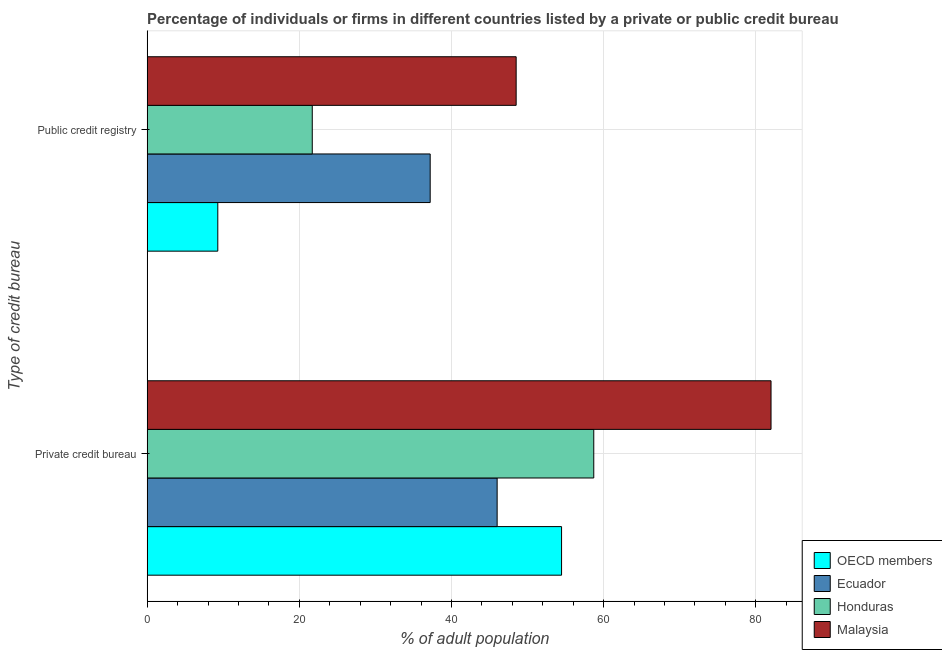How many different coloured bars are there?
Your answer should be compact. 4. Are the number of bars per tick equal to the number of legend labels?
Offer a terse response. Yes. Are the number of bars on each tick of the Y-axis equal?
Provide a succinct answer. Yes. How many bars are there on the 2nd tick from the top?
Make the answer very short. 4. How many bars are there on the 2nd tick from the bottom?
Offer a very short reply. 4. What is the label of the 1st group of bars from the top?
Your response must be concise. Public credit registry. What is the percentage of firms listed by private credit bureau in Malaysia?
Your answer should be compact. 82. Across all countries, what is the maximum percentage of firms listed by public credit bureau?
Give a very brief answer. 48.5. In which country was the percentage of firms listed by private credit bureau maximum?
Give a very brief answer. Malaysia. What is the total percentage of firms listed by public credit bureau in the graph?
Make the answer very short. 116.68. What is the difference between the percentage of firms listed by private credit bureau in OECD members and that in Honduras?
Provide a short and direct response. -4.23. What is the average percentage of firms listed by public credit bureau per country?
Provide a short and direct response. 29.17. What is the difference between the percentage of firms listed by public credit bureau and percentage of firms listed by private credit bureau in OECD members?
Provide a short and direct response. -45.18. What is the ratio of the percentage of firms listed by public credit bureau in Ecuador to that in Malaysia?
Provide a succinct answer. 0.77. What does the 2nd bar from the top in Public credit registry represents?
Your answer should be compact. Honduras. What does the 3rd bar from the bottom in Private credit bureau represents?
Your answer should be compact. Honduras. How many countries are there in the graph?
Provide a succinct answer. 4. Are the values on the major ticks of X-axis written in scientific E-notation?
Your answer should be very brief. No. Does the graph contain any zero values?
Your answer should be very brief. No. Where does the legend appear in the graph?
Provide a succinct answer. Bottom right. What is the title of the graph?
Your answer should be compact. Percentage of individuals or firms in different countries listed by a private or public credit bureau. What is the label or title of the X-axis?
Make the answer very short. % of adult population. What is the label or title of the Y-axis?
Ensure brevity in your answer.  Type of credit bureau. What is the % of adult population of OECD members in Private credit bureau?
Give a very brief answer. 54.47. What is the % of adult population in Honduras in Private credit bureau?
Make the answer very short. 58.7. What is the % of adult population of OECD members in Public credit registry?
Offer a very short reply. 9.28. What is the % of adult population in Ecuador in Public credit registry?
Provide a short and direct response. 37.2. What is the % of adult population of Honduras in Public credit registry?
Offer a very short reply. 21.7. What is the % of adult population in Malaysia in Public credit registry?
Provide a succinct answer. 48.5. Across all Type of credit bureau, what is the maximum % of adult population in OECD members?
Your answer should be very brief. 54.47. Across all Type of credit bureau, what is the maximum % of adult population in Ecuador?
Offer a terse response. 46. Across all Type of credit bureau, what is the maximum % of adult population in Honduras?
Make the answer very short. 58.7. Across all Type of credit bureau, what is the maximum % of adult population in Malaysia?
Ensure brevity in your answer.  82. Across all Type of credit bureau, what is the minimum % of adult population of OECD members?
Offer a terse response. 9.28. Across all Type of credit bureau, what is the minimum % of adult population of Ecuador?
Keep it short and to the point. 37.2. Across all Type of credit bureau, what is the minimum % of adult population in Honduras?
Keep it short and to the point. 21.7. Across all Type of credit bureau, what is the minimum % of adult population of Malaysia?
Your response must be concise. 48.5. What is the total % of adult population of OECD members in the graph?
Provide a short and direct response. 63.75. What is the total % of adult population of Ecuador in the graph?
Ensure brevity in your answer.  83.2. What is the total % of adult population of Honduras in the graph?
Your response must be concise. 80.4. What is the total % of adult population in Malaysia in the graph?
Provide a succinct answer. 130.5. What is the difference between the % of adult population in OECD members in Private credit bureau and that in Public credit registry?
Provide a short and direct response. 45.18. What is the difference between the % of adult population of Ecuador in Private credit bureau and that in Public credit registry?
Provide a short and direct response. 8.8. What is the difference between the % of adult population in Malaysia in Private credit bureau and that in Public credit registry?
Keep it short and to the point. 33.5. What is the difference between the % of adult population in OECD members in Private credit bureau and the % of adult population in Ecuador in Public credit registry?
Your answer should be compact. 17.27. What is the difference between the % of adult population of OECD members in Private credit bureau and the % of adult population of Honduras in Public credit registry?
Your response must be concise. 32.77. What is the difference between the % of adult population in OECD members in Private credit bureau and the % of adult population in Malaysia in Public credit registry?
Ensure brevity in your answer.  5.97. What is the difference between the % of adult population in Ecuador in Private credit bureau and the % of adult population in Honduras in Public credit registry?
Make the answer very short. 24.3. What is the difference between the % of adult population of Ecuador in Private credit bureau and the % of adult population of Malaysia in Public credit registry?
Your answer should be compact. -2.5. What is the difference between the % of adult population in Honduras in Private credit bureau and the % of adult population in Malaysia in Public credit registry?
Ensure brevity in your answer.  10.2. What is the average % of adult population of OECD members per Type of credit bureau?
Give a very brief answer. 31.88. What is the average % of adult population in Ecuador per Type of credit bureau?
Your answer should be very brief. 41.6. What is the average % of adult population in Honduras per Type of credit bureau?
Offer a very short reply. 40.2. What is the average % of adult population of Malaysia per Type of credit bureau?
Your answer should be compact. 65.25. What is the difference between the % of adult population in OECD members and % of adult population in Ecuador in Private credit bureau?
Your answer should be compact. 8.47. What is the difference between the % of adult population of OECD members and % of adult population of Honduras in Private credit bureau?
Make the answer very short. -4.23. What is the difference between the % of adult population of OECD members and % of adult population of Malaysia in Private credit bureau?
Offer a very short reply. -27.53. What is the difference between the % of adult population in Ecuador and % of adult population in Malaysia in Private credit bureau?
Your answer should be very brief. -36. What is the difference between the % of adult population of Honduras and % of adult population of Malaysia in Private credit bureau?
Give a very brief answer. -23.3. What is the difference between the % of adult population of OECD members and % of adult population of Ecuador in Public credit registry?
Offer a terse response. -27.92. What is the difference between the % of adult population of OECD members and % of adult population of Honduras in Public credit registry?
Ensure brevity in your answer.  -12.42. What is the difference between the % of adult population in OECD members and % of adult population in Malaysia in Public credit registry?
Your answer should be very brief. -39.22. What is the difference between the % of adult population in Ecuador and % of adult population in Honduras in Public credit registry?
Provide a short and direct response. 15.5. What is the difference between the % of adult population in Honduras and % of adult population in Malaysia in Public credit registry?
Provide a short and direct response. -26.8. What is the ratio of the % of adult population in OECD members in Private credit bureau to that in Public credit registry?
Offer a very short reply. 5.87. What is the ratio of the % of adult population of Ecuador in Private credit bureau to that in Public credit registry?
Give a very brief answer. 1.24. What is the ratio of the % of adult population of Honduras in Private credit bureau to that in Public credit registry?
Your answer should be compact. 2.71. What is the ratio of the % of adult population in Malaysia in Private credit bureau to that in Public credit registry?
Your answer should be compact. 1.69. What is the difference between the highest and the second highest % of adult population of OECD members?
Keep it short and to the point. 45.18. What is the difference between the highest and the second highest % of adult population of Malaysia?
Offer a terse response. 33.5. What is the difference between the highest and the lowest % of adult population of OECD members?
Your answer should be compact. 45.18. What is the difference between the highest and the lowest % of adult population in Malaysia?
Give a very brief answer. 33.5. 